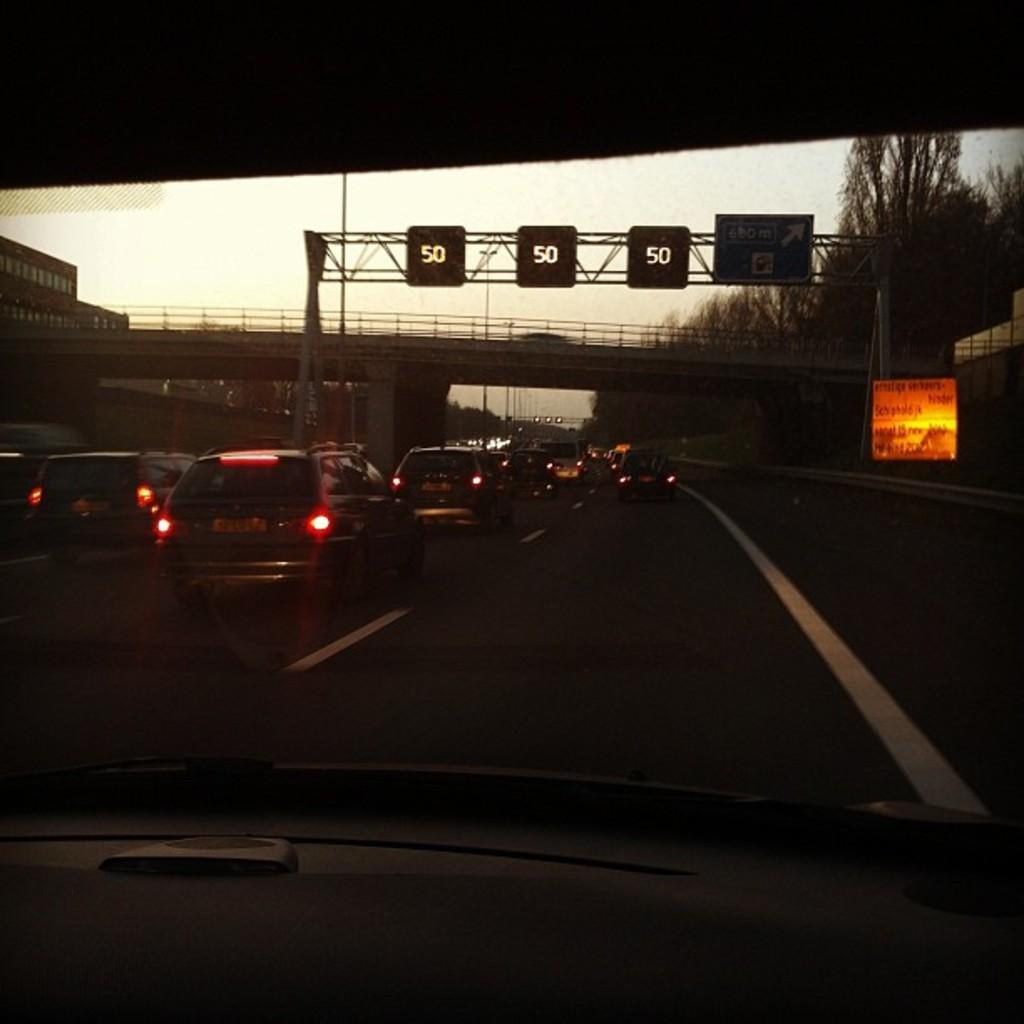What is the perspective of the image? The image is viewed from inside a vehicle. What can be seen on the ground in the image? There is a road visible in the image, with vehicles on it. What type of structure is present in the image? There is a bridge in the image. What are the poles used for in the image? The poles are likely used for supporting wires or signs. What information is displayed on the boards in the image? There are boards with numbers in the image, and there is text visible on them. What type of vegetation is present in the image? There are trees in the image. What is visible in the sky in the image? The sky is visible in the image. What type of jam is being prepared on the stove in the image? There is no stove or jam present in the image; it is a view from inside a vehicle. What type of shock can be seen on the faces of the people in the image? There are no people present in the image, so it is not possible to determine their facial expressions or any potential shock. 